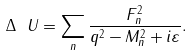<formula> <loc_0><loc_0><loc_500><loc_500>\Delta _ { \ } U = \sum _ { n } \frac { F _ { n } ^ { 2 } } { q ^ { 2 } - M _ { n } ^ { 2 } + i \varepsilon } .</formula> 